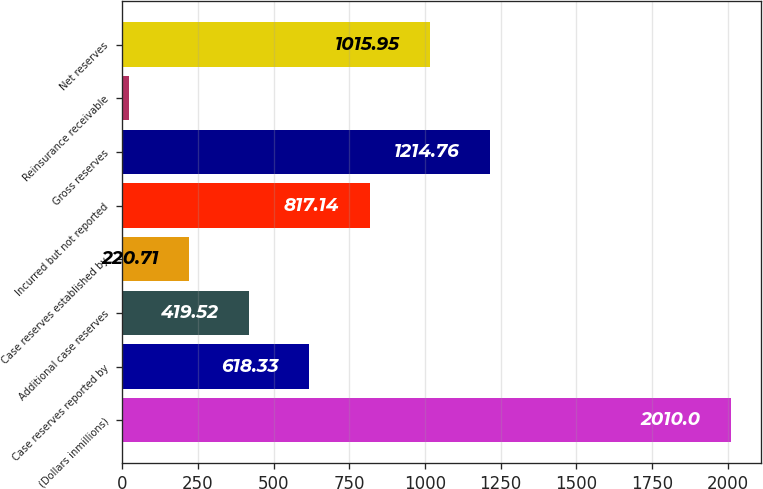Convert chart. <chart><loc_0><loc_0><loc_500><loc_500><bar_chart><fcel>(Dollars inmillions)<fcel>Case reserves reported by<fcel>Additional case reserves<fcel>Case reserves established by<fcel>Incurred but not reported<fcel>Gross reserves<fcel>Reinsurance receivable<fcel>Net reserves<nl><fcel>2010<fcel>618.33<fcel>419.52<fcel>220.71<fcel>817.14<fcel>1214.76<fcel>21.9<fcel>1015.95<nl></chart> 